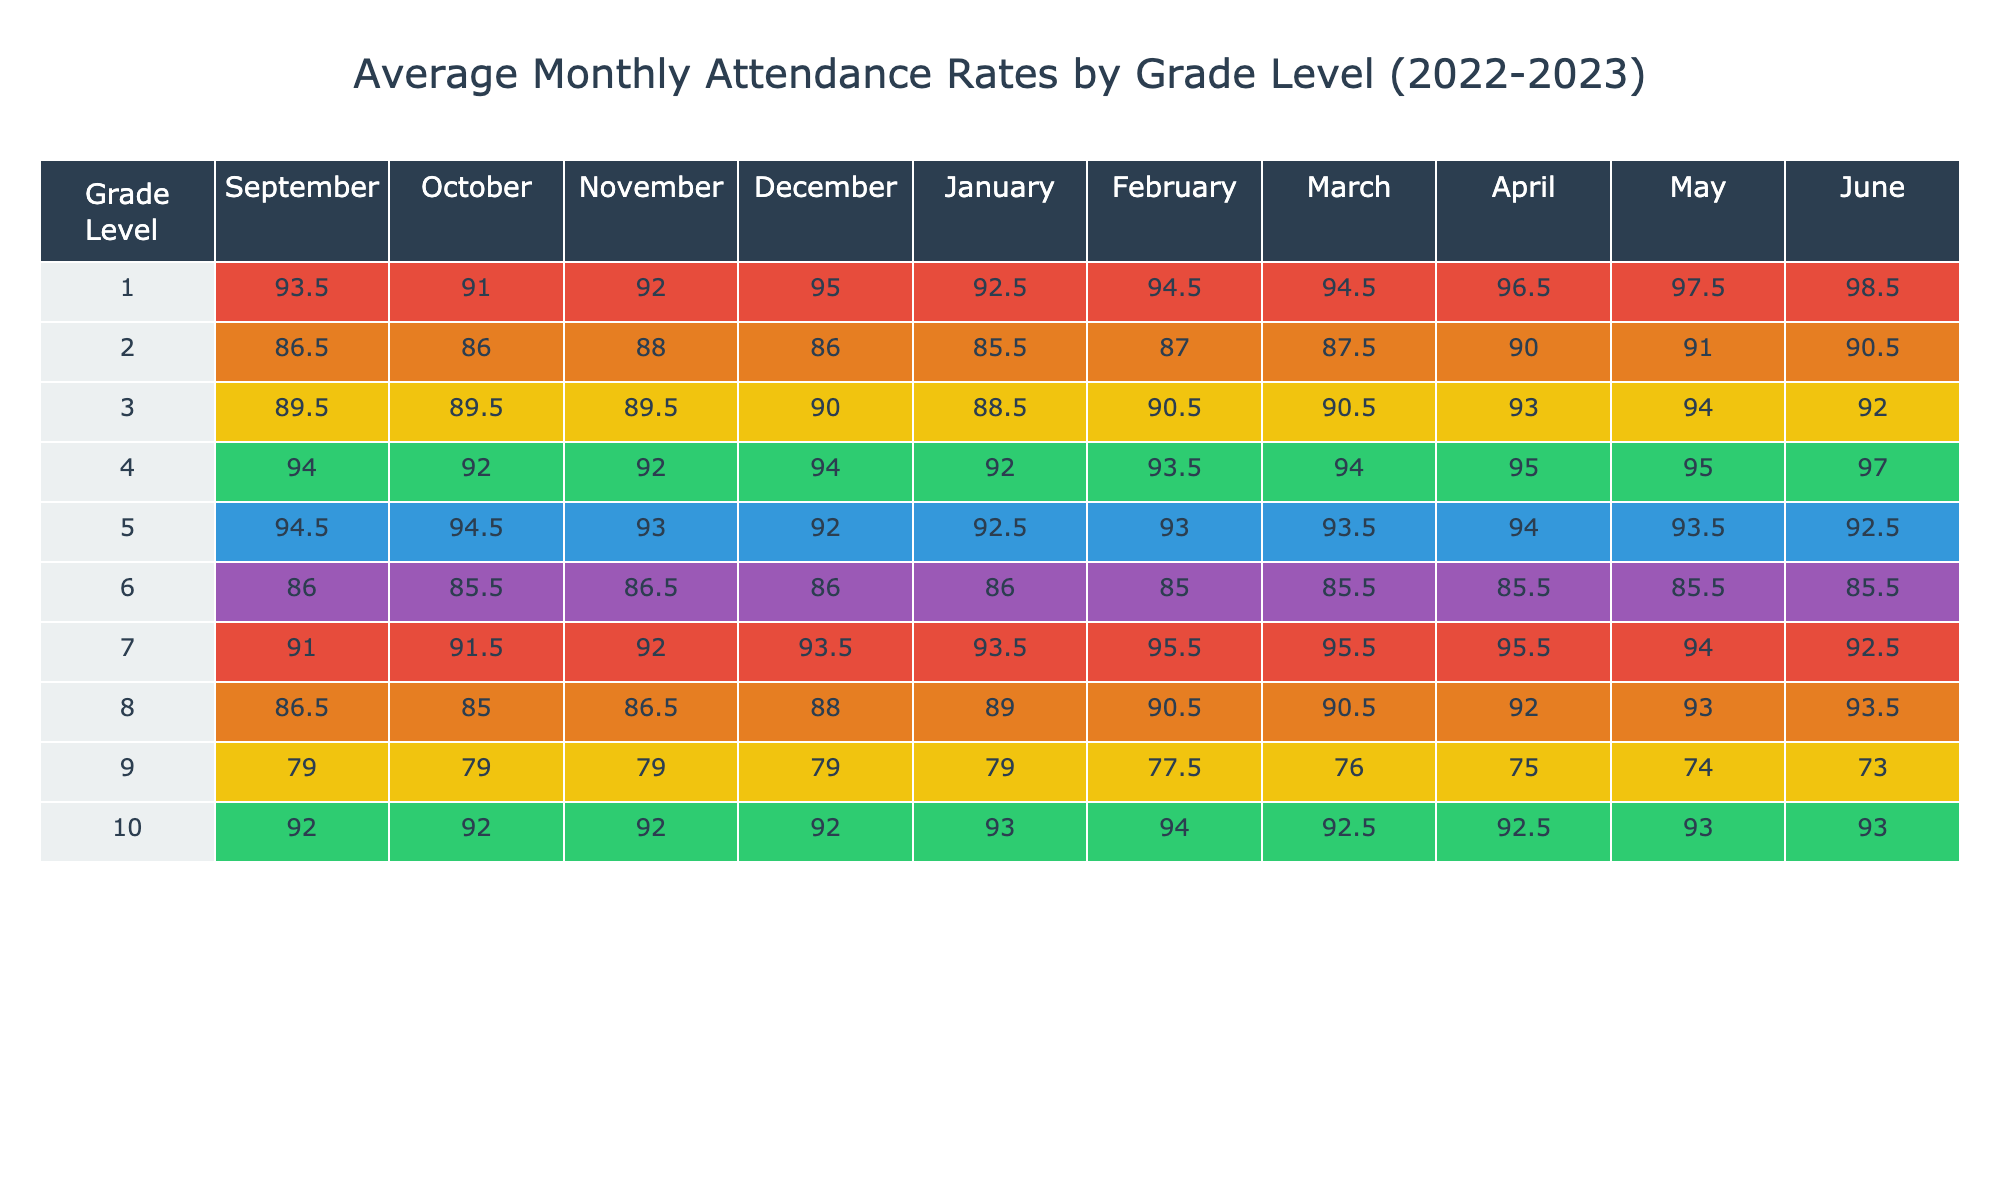What is the average attendance rate for Grade 3 in February? For Grade 3, the attendance rates in February are 93 and 88 (for the two students). Adding them gives a total of 181. There are 2 students, so the average is 181/2 = 90.5.
Answer: 90.5 Which month had the highest average attendance for Grade 7? The average attendance rates for Grade 7 across the months are: September: 91, October: 91.5, November: 92, December: 93.5, January: 93.5, February: 95.5, March: 95.5, April: 95.5, May: 94, June: 92. This shows that February had the highest average of 95.5.
Answer: February Did Grade 9 have an average attendance rate above 80% in March? The average attendance for Grade 9 in March is 81 (from the two students, 80 and 82). Since 81 is above 80, the answer is yes.
Answer: Yes What is the difference in average attendance between Grade 5 in April and Grade 6 in April? Grade 5's average in April is 94.5 and Grade 6's average in April is 84.5. The difference would be 94.5 - 84.5 = 10.
Answer: 10 Which grade had the lowest average attendance for the month of October? The average attendance rates for October by grade are: Grade 1: 91, Grade 2: 86, Grade 3: 89.5, Grade 4: 92, Grade 5: 95.5, Grade 6: 85.5, Grade 7: 89.5, Grade 8: 85.5, Grade 9: 79, and Grade 10: 88. Grade 9 had the lowest rate of 79.
Answer: Grade 9 What is the overall average attendance for Grade 10 for the entire school year? The attendance rates for Grade 10 across months are: September: 95, October: 88, November: 87, December: 86, January: 87, February: 92, March: 90, April: 91, May: 93, June: 94. Summing them gives 929, and dividing by 10 yields an average of 92.9.
Answer: 92.9 How does the average attendance in May compare for Grade 4 and Grade 8? For Grade 4, the average in May is 95, while for Grade 8, it is 90. Since 95 is greater than 90, Grade 4 had higher attendance in May.
Answer: Grade 4 had higher attendance Did any grade achieve an average attendance of 100% in June? Checking the June average attendance rates, no grade achieved an average of 100%. The highest is Grade 1 with 100, but not for the entire grade.
Answer: No 